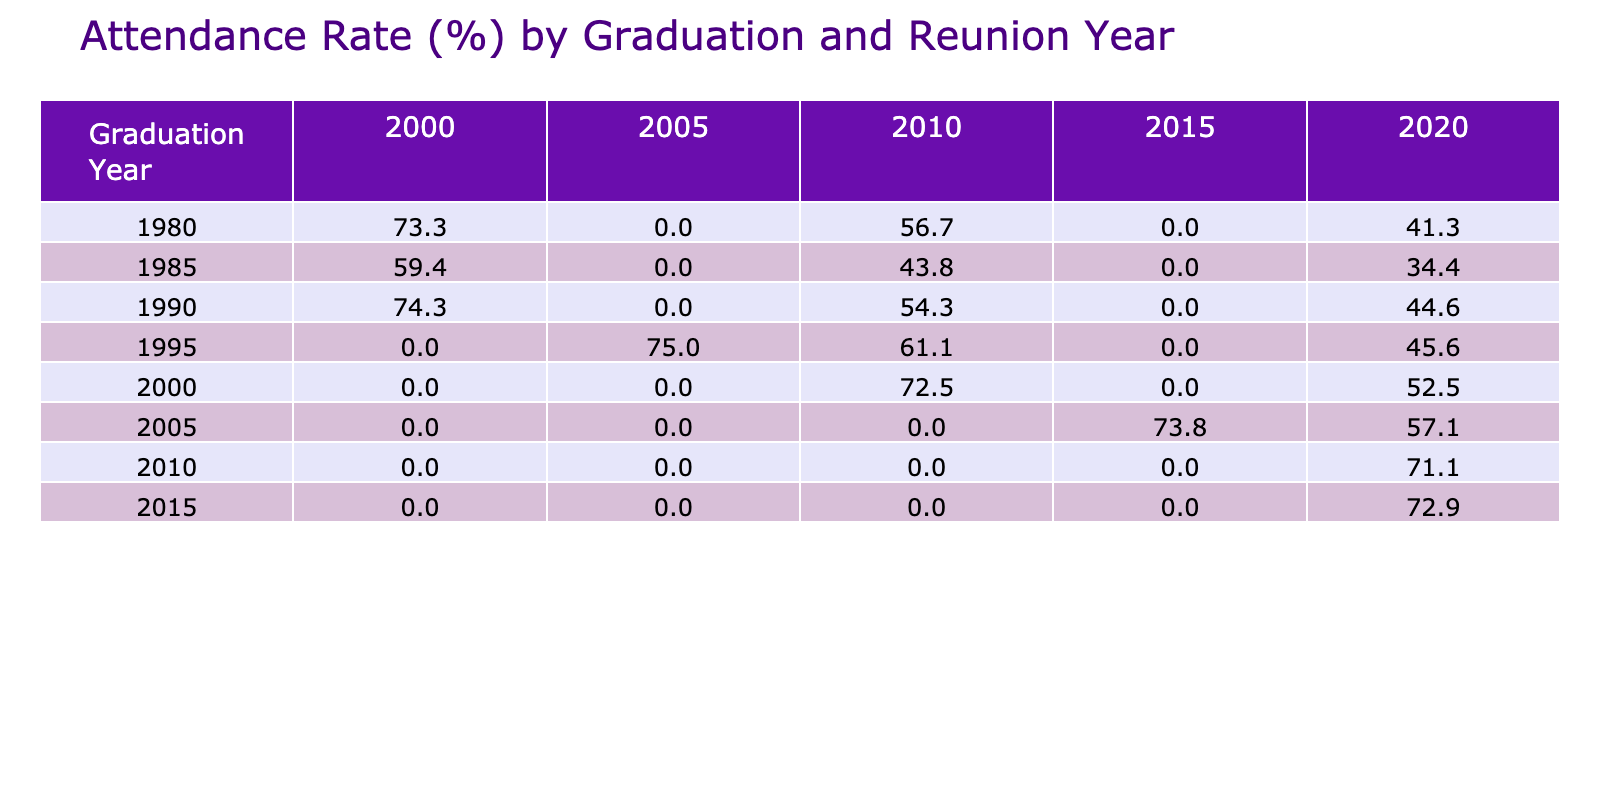What was the attendance rate for the 2015 graduation year in 2020? The table shows that the attendance rate for the 2015 graduation year in 2020 is presented directly in the relevant cell. Looking at the intersection of the "Graduation Year" 2015 and "Reunion Year" 2020, the value is 72.9%
Answer: 72.9% Which graduation year had the highest attendance rate in 2020? By comparing the values in the 2020 column across all graduation years, the highest attendance rate is for the 2010 graduation year at 71.1%. This involves examining each graduation year’s entry in that column and identifying the maximum value
Answer: 71.1% Is it true that the attendance rate for the 1990 graduation year increased over the years? To confirm this, we check the attendance rates for the 1990 graduation year over each reunion year: 1990 shows rates of 74.3% in 2000, 54.3% in 2010, and 44.6% in 2020. Since the values are decreasing, the statement is false
Answer: No What is the average attendance rate for the 1980 graduation year across all reunion years? Gather the attendance rates for the 1980 graduation year which are: 73.3% for 2000, 56.7% for 2010, and 41.3% for 2020. The total of these rates is 73.3 + 56.7 + 41.3 = 171.3%. There are three rates, so to find the average, we divide by 3, resulting in 171.3 / 3 = 57.1%
Answer: 57.1% Which reunion year had the lowest attendance rate across all graduation years? By examining each cell in the table, we find the minimum attendance rate. Looking through the data, the lowest attendance rate is 20.0% which occurs for the 1985 graduation year reunion in 2000
Answer: 20.0% 